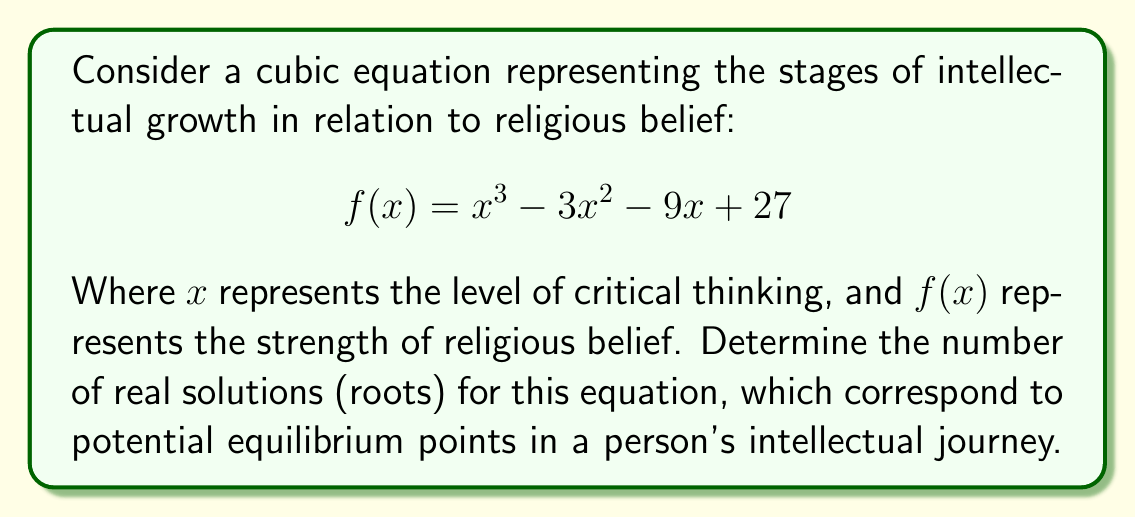Can you solve this math problem? To determine the number of real solutions for this cubic equation, we'll follow these steps:

1) First, let's calculate the discriminant of the cubic equation. For a cubic equation in the form $ax^3 + bx^2 + cx + d = 0$, the discriminant is given by:

   $$\Delta = 18abcd - 4b^3d + b^2c^2 - 4ac^3 - 27a^2d^2$$

2) In our case, $a=1$, $b=-3$, $c=-9$, and $d=27$. Let's substitute these values:

   $$\Delta = 18(1)(-3)(-9)(27) - 4(-3)^3(27) + (-3)^2(-9)^2 - 4(1)(-9)^3 - 27(1)^2(27)^2$$

3) Simplifying:

   $$\Delta = 13122 - 2916 + 6561 - (-11664) - 19683$$
   $$\Delta = 8748$$

4) Since $\Delta > 0$, the cubic equation has three distinct real roots.

This result aligns with the concept of intellectual growth in relation to religious belief. The three roots could represent:
1. A state of unquestioning belief
2. A transitional state of doubt and questioning
3. A state of informed skepticism or atheism

These stages mirror the journey that many, including celebrity atheists, describe in their intellectual growth regarding religion.
Answer: The cubic equation $f(x) = x^3 - 3x^2 - 9x + 27$ has 3 real solutions. 